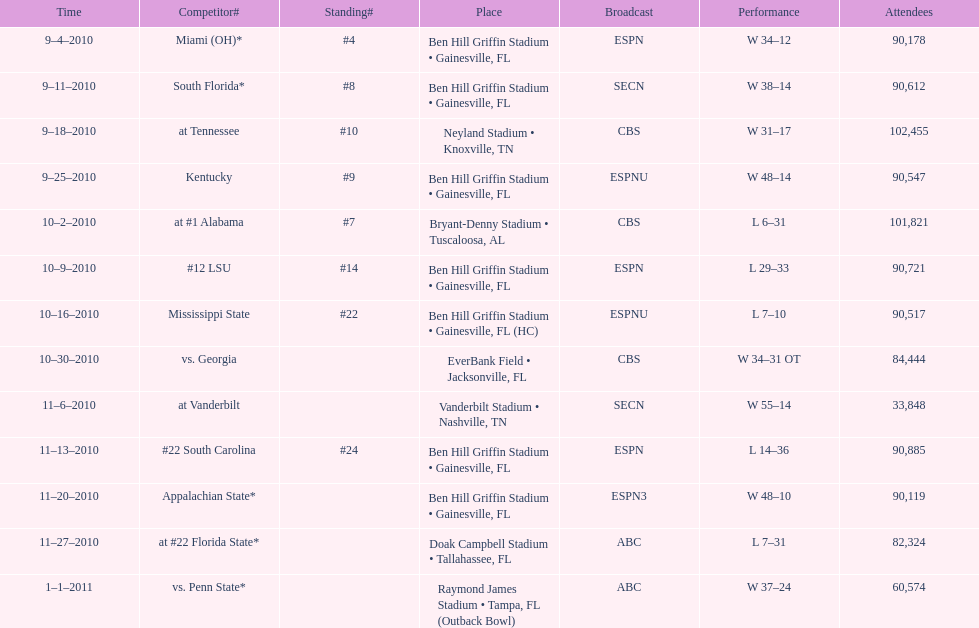What was the most the university of florida won by? 41 points. 